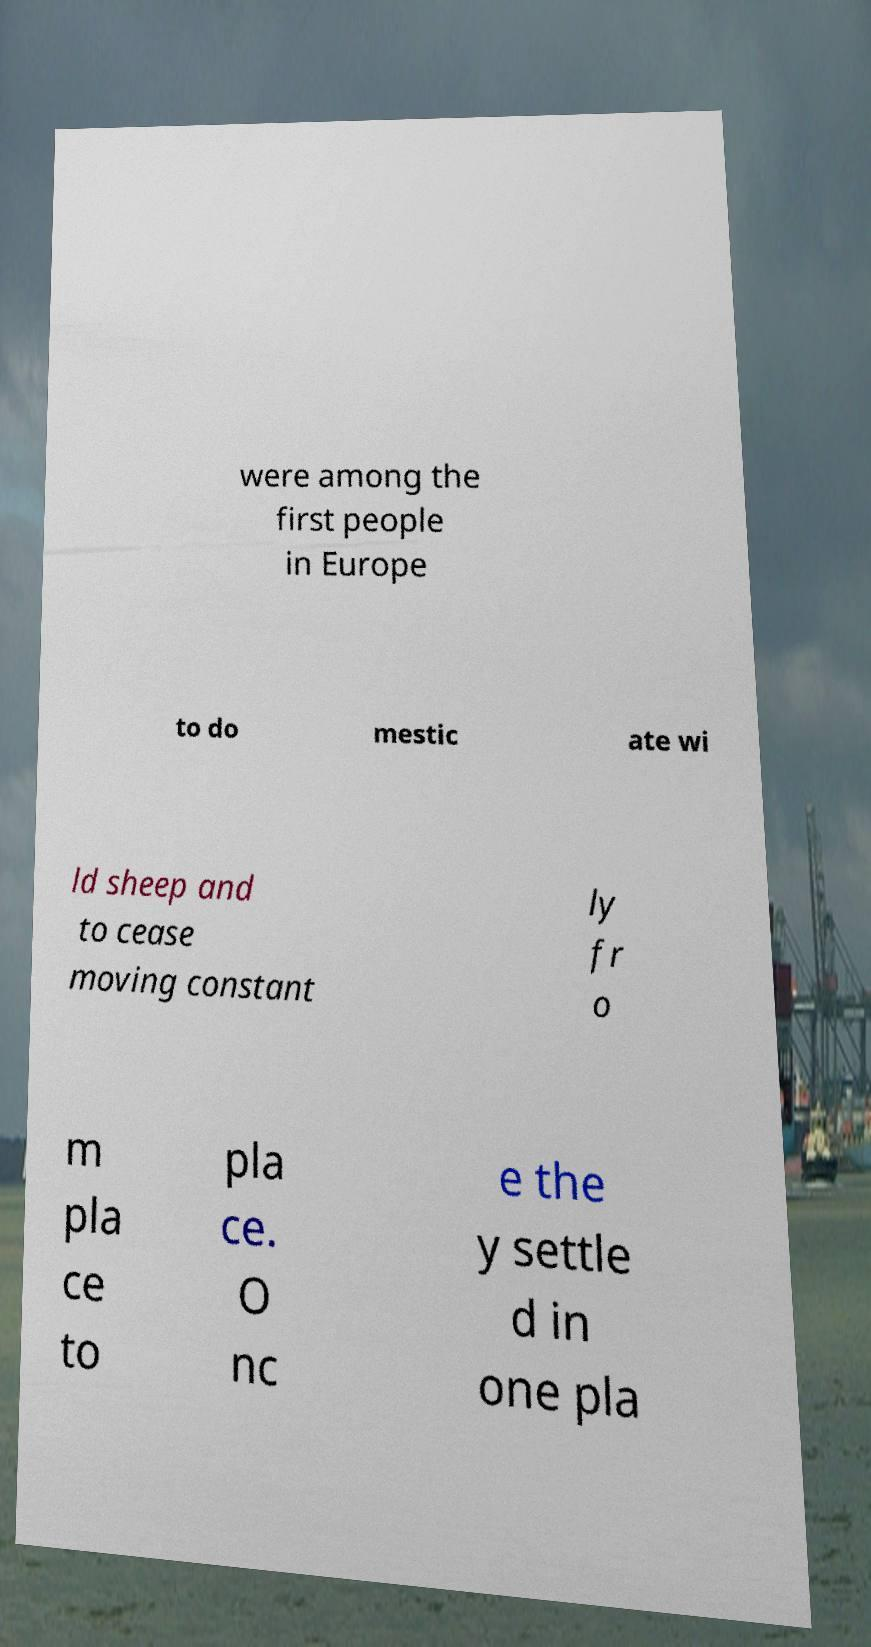For documentation purposes, I need the text within this image transcribed. Could you provide that? were among the first people in Europe to do mestic ate wi ld sheep and to cease moving constant ly fr o m pla ce to pla ce. O nc e the y settle d in one pla 